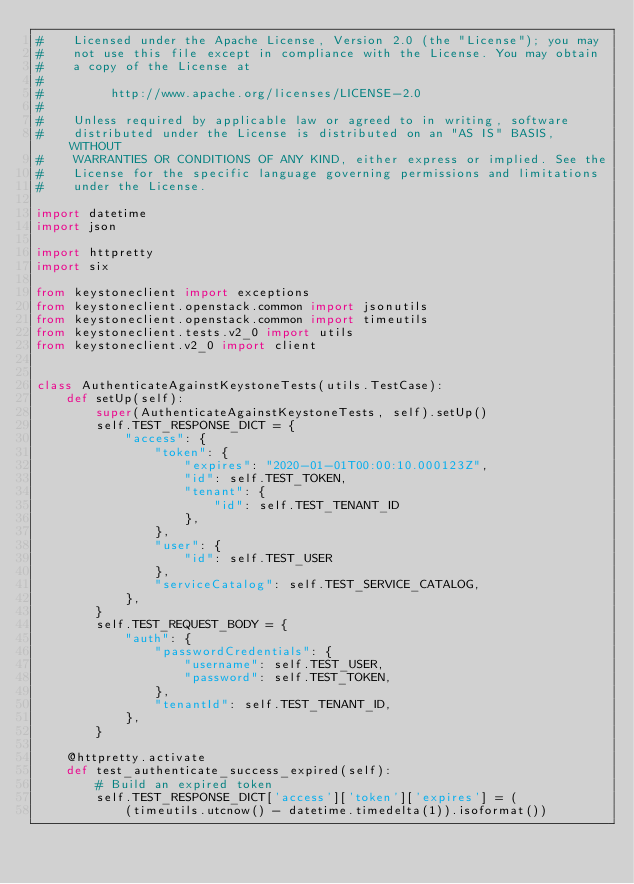Convert code to text. <code><loc_0><loc_0><loc_500><loc_500><_Python_>#    Licensed under the Apache License, Version 2.0 (the "License"); you may
#    not use this file except in compliance with the License. You may obtain
#    a copy of the License at
#
#         http://www.apache.org/licenses/LICENSE-2.0
#
#    Unless required by applicable law or agreed to in writing, software
#    distributed under the License is distributed on an "AS IS" BASIS, WITHOUT
#    WARRANTIES OR CONDITIONS OF ANY KIND, either express or implied. See the
#    License for the specific language governing permissions and limitations
#    under the License.

import datetime
import json

import httpretty
import six

from keystoneclient import exceptions
from keystoneclient.openstack.common import jsonutils
from keystoneclient.openstack.common import timeutils
from keystoneclient.tests.v2_0 import utils
from keystoneclient.v2_0 import client


class AuthenticateAgainstKeystoneTests(utils.TestCase):
    def setUp(self):
        super(AuthenticateAgainstKeystoneTests, self).setUp()
        self.TEST_RESPONSE_DICT = {
            "access": {
                "token": {
                    "expires": "2020-01-01T00:00:10.000123Z",
                    "id": self.TEST_TOKEN,
                    "tenant": {
                        "id": self.TEST_TENANT_ID
                    },
                },
                "user": {
                    "id": self.TEST_USER
                },
                "serviceCatalog": self.TEST_SERVICE_CATALOG,
            },
        }
        self.TEST_REQUEST_BODY = {
            "auth": {
                "passwordCredentials": {
                    "username": self.TEST_USER,
                    "password": self.TEST_TOKEN,
                },
                "tenantId": self.TEST_TENANT_ID,
            },
        }

    @httpretty.activate
    def test_authenticate_success_expired(self):
        # Build an expired token
        self.TEST_RESPONSE_DICT['access']['token']['expires'] = (
            (timeutils.utcnow() - datetime.timedelta(1)).isoformat())
</code> 